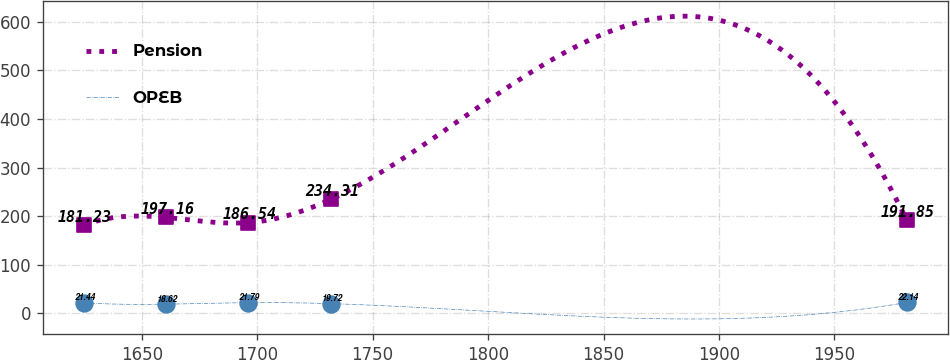Convert chart to OTSL. <chart><loc_0><loc_0><loc_500><loc_500><line_chart><ecel><fcel>Pension<fcel>OPEB<nl><fcel>1624.86<fcel>181.23<fcel>21.44<nl><fcel>1660.51<fcel>197.16<fcel>18.62<nl><fcel>1696.16<fcel>186.54<fcel>21.79<nl><fcel>1731.81<fcel>234.31<fcel>19.72<nl><fcel>1981.34<fcel>191.85<fcel>22.14<nl></chart> 